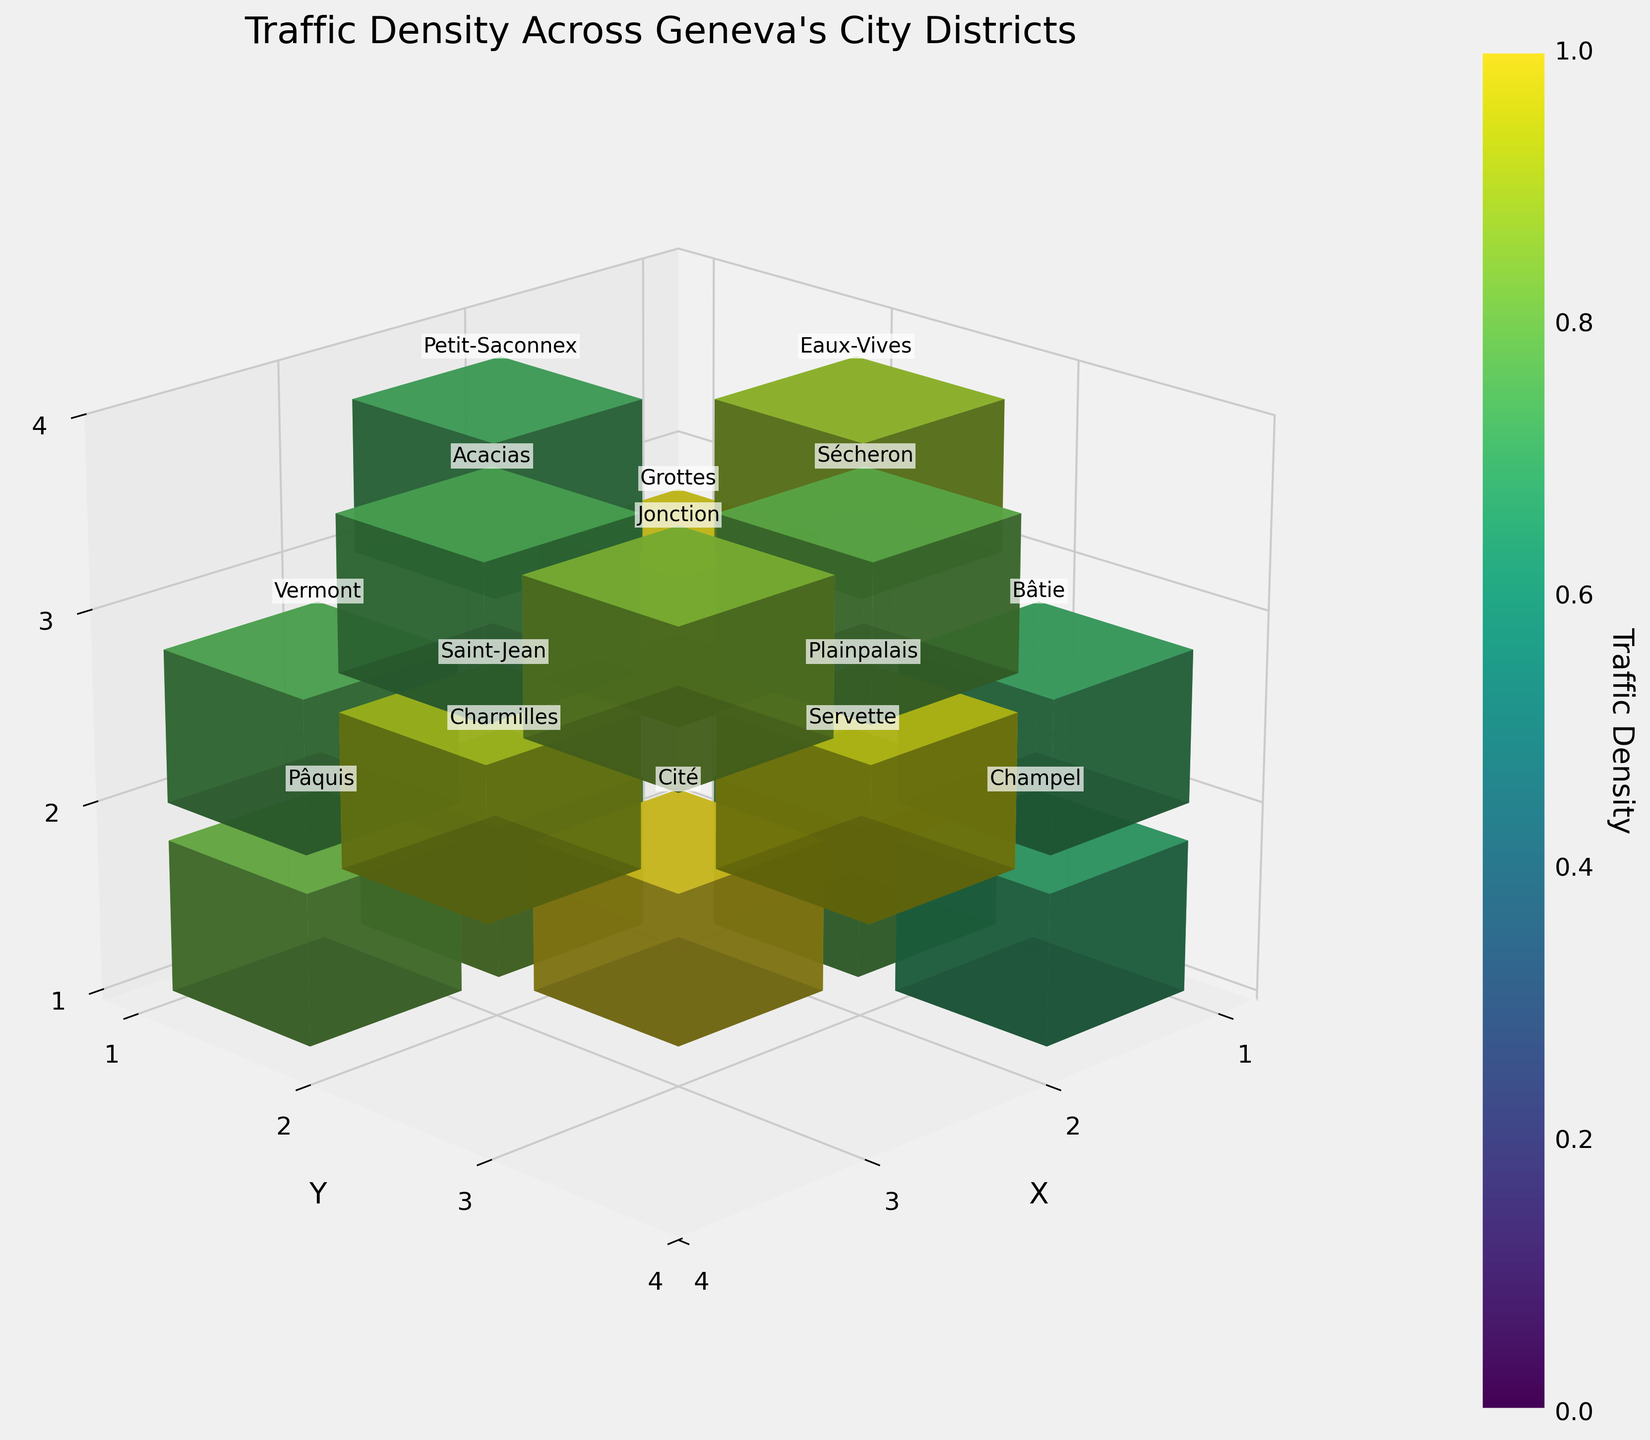What is the title of the figure? The title of the figure is displayed at the top of the plot.
Answer: Traffic Density Across Geneva's City Districts Which axis represents the X-coordinates, and what is its label? The X-coordinate axis is labeled 'X' and is positioned horizontally in the 3D space.
Answer: X What color scheme is used to represent the traffic density in the plot? The colors in the plot range from dark to bright, following a gradient which suggests the use of a 'viridis' colormap where darker colors represent lower density and brighter colors represent higher density.
Answer: 'viridis' How many districts are represented in the figure? The districts are indicated by their names in the figure and can be counted.
Answer: 15 What district has the highest traffic density, and what is its value? The district with the highest traffic density will have the brightest color and the highest bar. Reading the labels, it's 'Cité' with a value of 97.
Answer: Cité, 97 What district has the lowest traffic density, and what is its value? The district with the lowest traffic density will have the darkest color and the shortest bar. The label indicates 'Champel' with a value of 65.
Answer: Champel, 65 How does the traffic density in Plainpalais compare to that in Saint-Jean? Plainpalais and Saint-Jean can be compared visually by observing the heights of their bars. Plainpalais has a density of 92, while Saint-Jean has a density of 88.
Answer: Plainpalais is higher Which district is located at the coordinates (3, 2, 3) and what is its traffic density? By matching the coordinates (3, 2, 3) to the labels, the district is 'Acacias' with a density of 72.
Answer: Acacias, 72 What is the average traffic density across all districts? To calculate the average, sum all the traffic densities and divide by the number of districts: (85 + 92 + 78 + 70 + 65 + 88 + 95 + 97 + 82 + 75 + 80 + 72 + 68 + 76 + 73) / 15 = 78.6
Answer: 78.6 Which district has a traffic density closest to the average density? The calculated average density is 78.6. Reviewing the traffic densities, 'Pâquis' at 78 and 'Vermont' at 73 are closest. Pâquis is closer with a value of 78.
Answer: Pâquis 